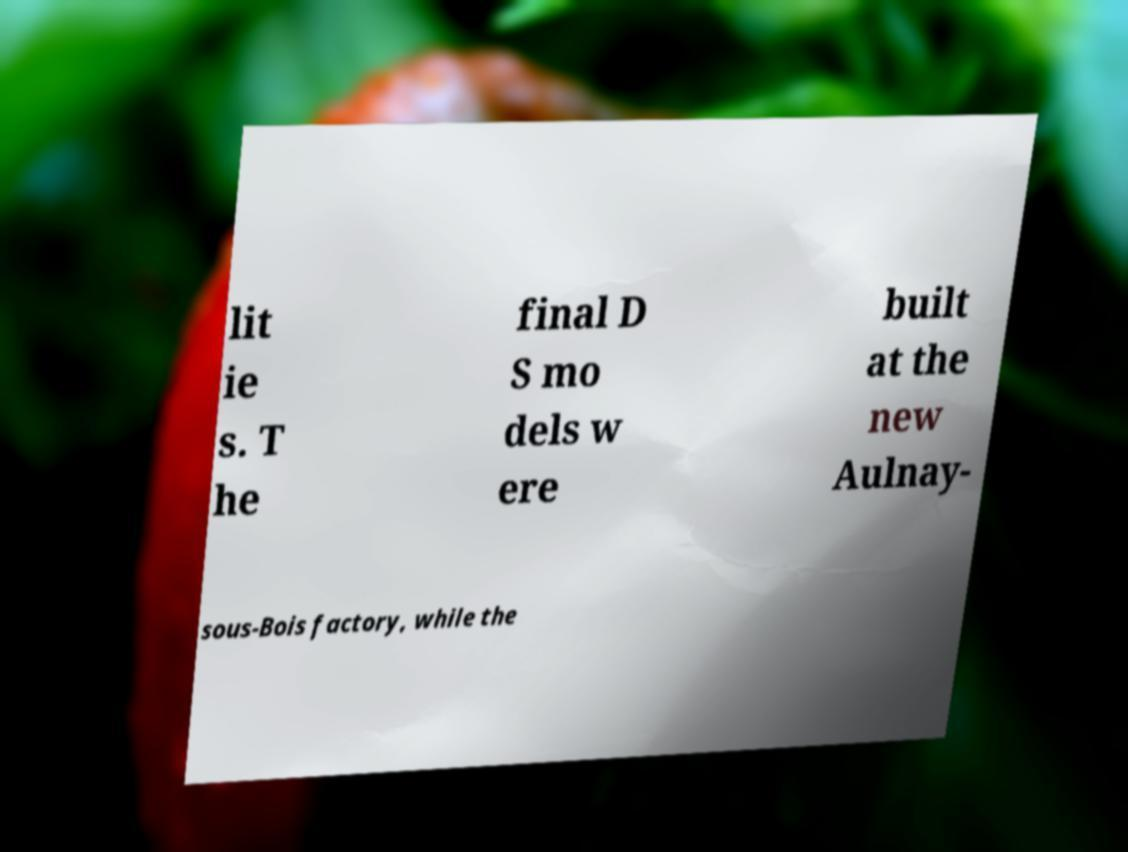Can you accurately transcribe the text from the provided image for me? lit ie s. T he final D S mo dels w ere built at the new Aulnay- sous-Bois factory, while the 